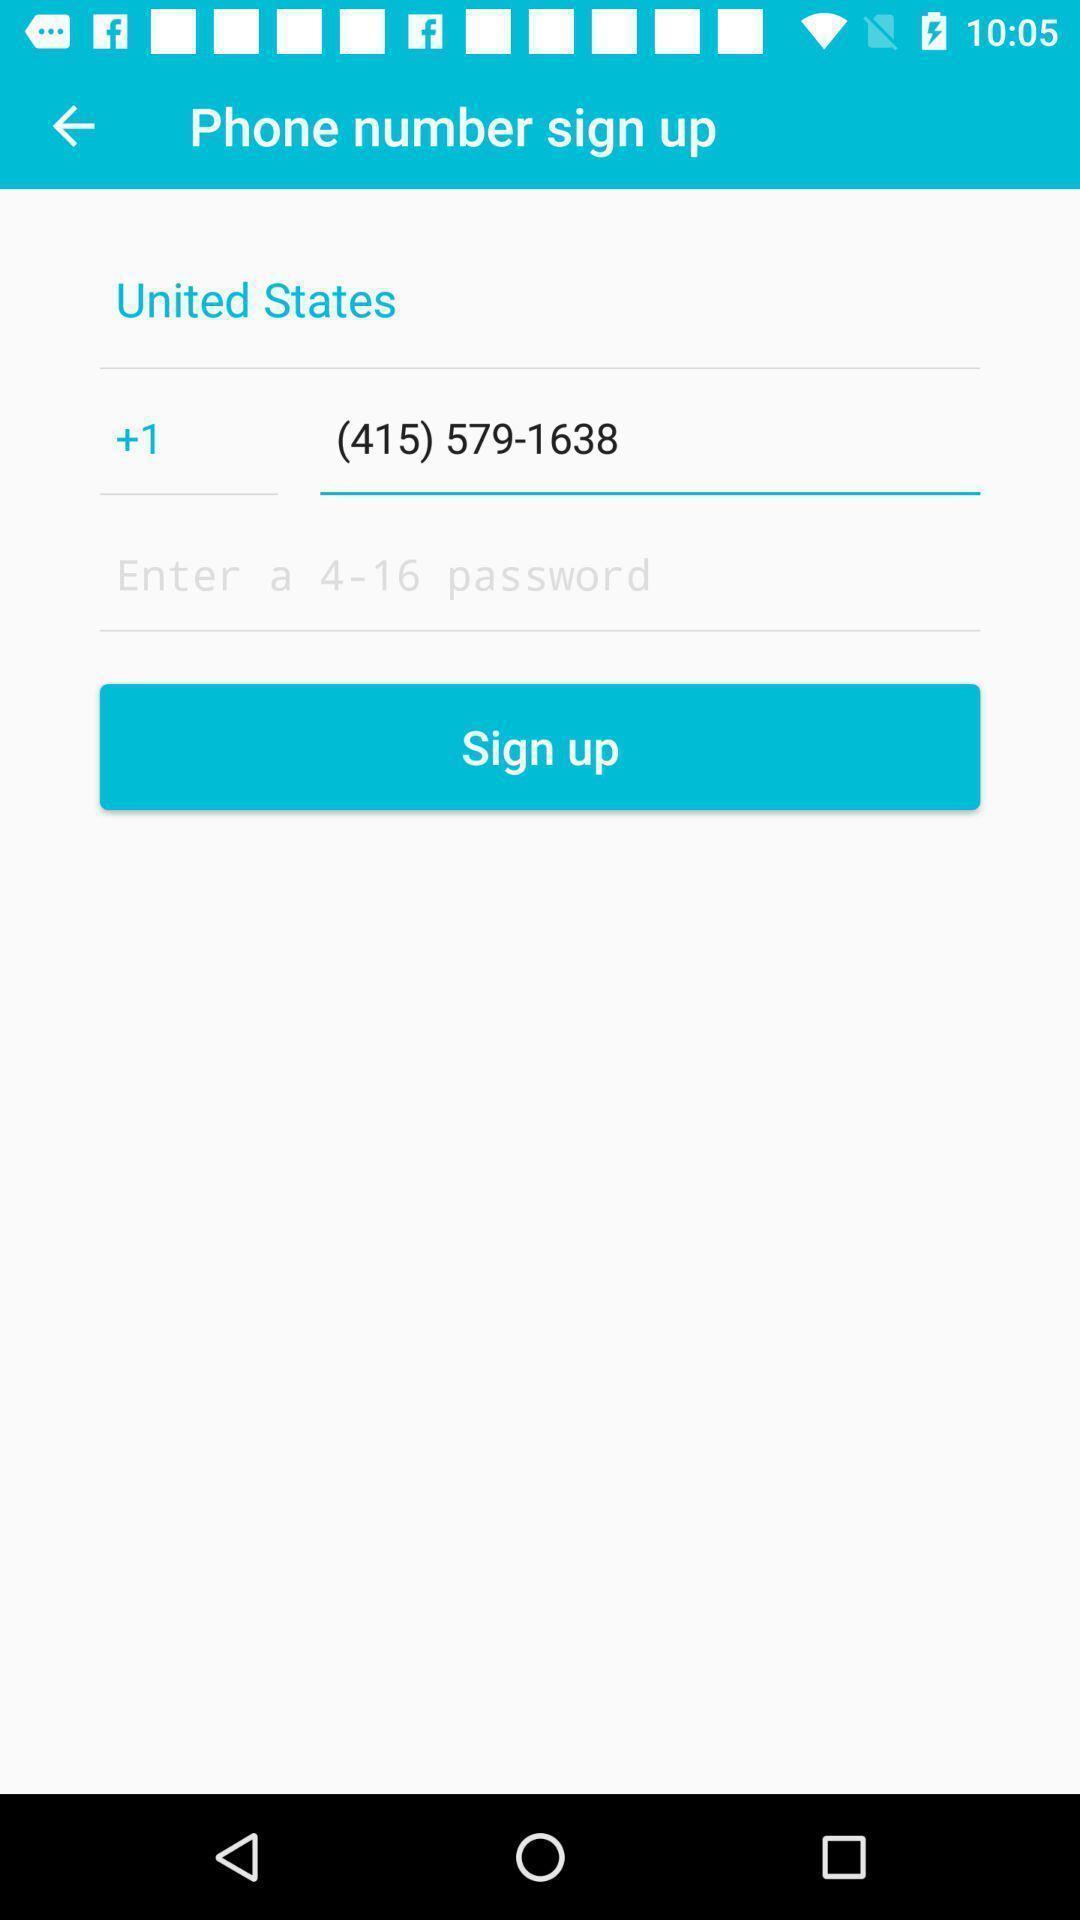What is the overall content of this screenshot? Page showing to sign up with phone number. 